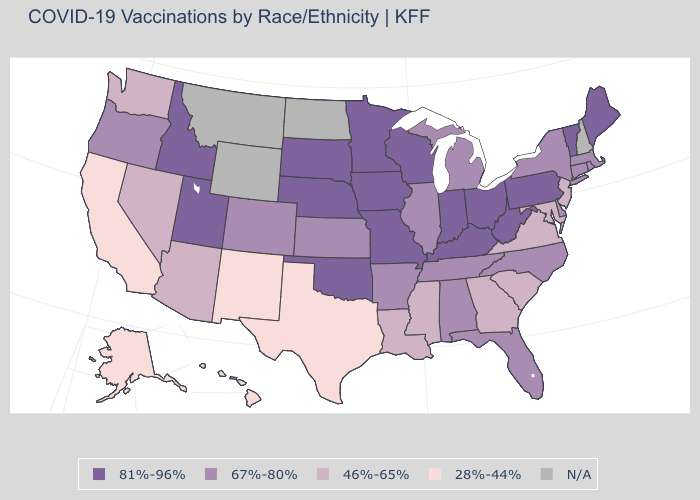Among the states that border Connecticut , which have the lowest value?
Keep it brief. Massachusetts, New York, Rhode Island. Which states have the lowest value in the USA?
Answer briefly. Alaska, California, Hawaii, New Mexico, Texas. What is the highest value in the USA?
Short answer required. 81%-96%. How many symbols are there in the legend?
Keep it brief. 5. Does Arizona have the highest value in the West?
Be succinct. No. Among the states that border Kansas , which have the lowest value?
Write a very short answer. Colorado. Name the states that have a value in the range 46%-65%?
Be succinct. Arizona, Georgia, Louisiana, Maryland, Mississippi, Nevada, New Jersey, South Carolina, Virginia, Washington. Which states have the highest value in the USA?
Be succinct. Idaho, Indiana, Iowa, Kentucky, Maine, Minnesota, Missouri, Nebraska, Ohio, Oklahoma, Pennsylvania, South Dakota, Utah, Vermont, West Virginia, Wisconsin. What is the value of Wisconsin?
Give a very brief answer. 81%-96%. Does Utah have the highest value in the West?
Concise answer only. Yes. Name the states that have a value in the range 46%-65%?
Be succinct. Arizona, Georgia, Louisiana, Maryland, Mississippi, Nevada, New Jersey, South Carolina, Virginia, Washington. Name the states that have a value in the range 81%-96%?
Answer briefly. Idaho, Indiana, Iowa, Kentucky, Maine, Minnesota, Missouri, Nebraska, Ohio, Oklahoma, Pennsylvania, South Dakota, Utah, Vermont, West Virginia, Wisconsin. What is the highest value in the USA?
Concise answer only. 81%-96%. Does the map have missing data?
Short answer required. Yes. Name the states that have a value in the range 81%-96%?
Write a very short answer. Idaho, Indiana, Iowa, Kentucky, Maine, Minnesota, Missouri, Nebraska, Ohio, Oklahoma, Pennsylvania, South Dakota, Utah, Vermont, West Virginia, Wisconsin. 